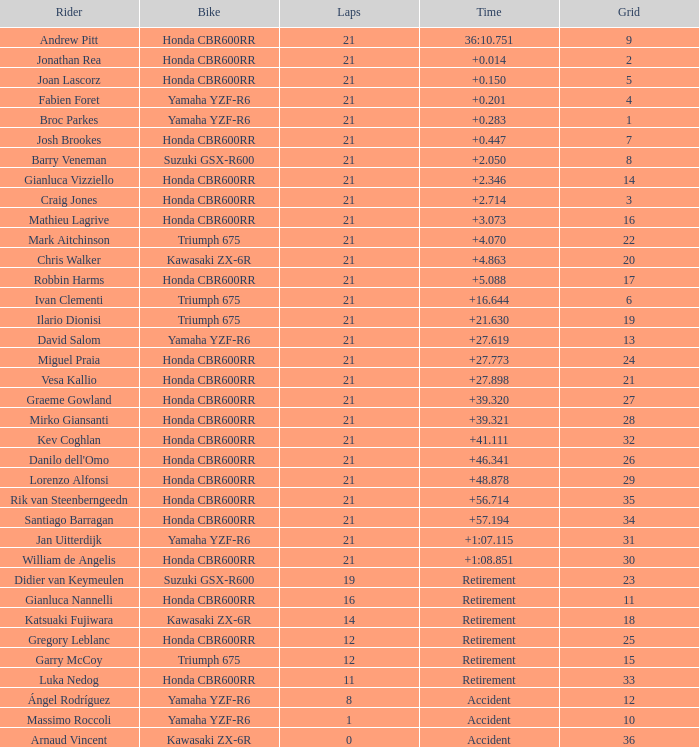What is the highest number of laps completed by ilario dionisi? 21.0. 